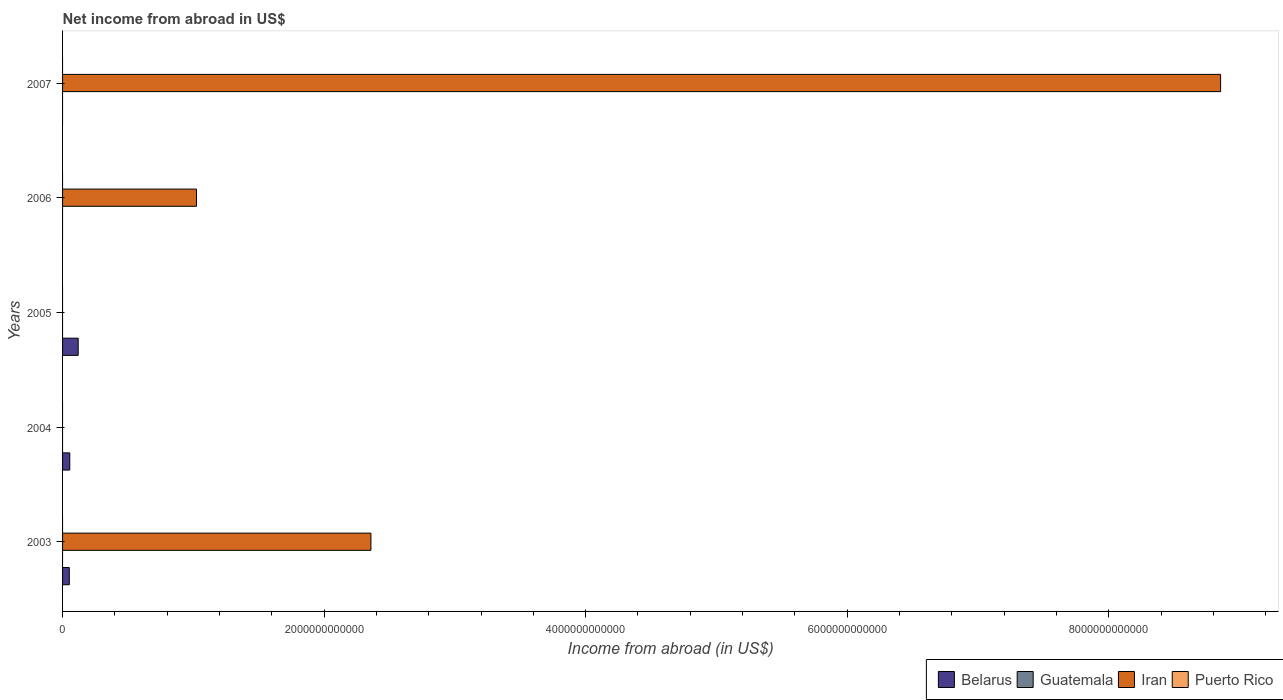Are the number of bars on each tick of the Y-axis equal?
Your answer should be very brief. No. What is the label of the 1st group of bars from the top?
Offer a very short reply. 2007. Across all years, what is the maximum net income from abroad in Iran?
Your answer should be very brief. 8.86e+12. Across all years, what is the minimum net income from abroad in Puerto Rico?
Offer a very short reply. 0. What is the difference between the net income from abroad in Iran in 2003 and that in 2006?
Your response must be concise. 1.33e+12. What is the difference between the net income from abroad in Belarus in 2007 and the net income from abroad in Iran in 2003?
Offer a very short reply. -2.36e+12. What is the average net income from abroad in Iran per year?
Offer a terse response. 2.45e+12. In the year 2003, what is the difference between the net income from abroad in Belarus and net income from abroad in Iran?
Your response must be concise. -2.31e+12. In how many years, is the net income from abroad in Belarus greater than 6000000000000 US$?
Your response must be concise. 0. What is the ratio of the net income from abroad in Belarus in 2004 to that in 2005?
Provide a short and direct response. 0.46. What is the difference between the highest and the lowest net income from abroad in Belarus?
Give a very brief answer. 1.20e+11. Is it the case that in every year, the sum of the net income from abroad in Belarus and net income from abroad in Iran is greater than the sum of net income from abroad in Puerto Rico and net income from abroad in Guatemala?
Your response must be concise. No. Is it the case that in every year, the sum of the net income from abroad in Guatemala and net income from abroad in Belarus is greater than the net income from abroad in Puerto Rico?
Your response must be concise. No. How many years are there in the graph?
Offer a very short reply. 5. What is the difference between two consecutive major ticks on the X-axis?
Ensure brevity in your answer.  2.00e+12. Are the values on the major ticks of X-axis written in scientific E-notation?
Keep it short and to the point. No. Does the graph contain grids?
Your answer should be compact. No. Where does the legend appear in the graph?
Provide a short and direct response. Bottom right. How many legend labels are there?
Give a very brief answer. 4. What is the title of the graph?
Your answer should be very brief. Net income from abroad in US$. Does "Middle East & North Africa (all income levels)" appear as one of the legend labels in the graph?
Provide a succinct answer. No. What is the label or title of the X-axis?
Provide a short and direct response. Income from abroad (in US$). What is the Income from abroad (in US$) in Belarus in 2003?
Your answer should be very brief. 5.15e+1. What is the Income from abroad (in US$) of Iran in 2003?
Keep it short and to the point. 2.36e+12. What is the Income from abroad (in US$) in Puerto Rico in 2003?
Make the answer very short. 0. What is the Income from abroad (in US$) in Belarus in 2004?
Your response must be concise. 5.51e+1. What is the Income from abroad (in US$) of Guatemala in 2004?
Ensure brevity in your answer.  0. What is the Income from abroad (in US$) of Iran in 2004?
Your answer should be compact. 0. What is the Income from abroad (in US$) in Puerto Rico in 2004?
Provide a succinct answer. 0. What is the Income from abroad (in US$) in Belarus in 2005?
Your answer should be very brief. 1.20e+11. What is the Income from abroad (in US$) in Guatemala in 2005?
Your answer should be very brief. 0. What is the Income from abroad (in US$) in Puerto Rico in 2005?
Provide a succinct answer. 0. What is the Income from abroad (in US$) of Iran in 2006?
Ensure brevity in your answer.  1.02e+12. What is the Income from abroad (in US$) in Puerto Rico in 2006?
Your answer should be very brief. 0. What is the Income from abroad (in US$) of Iran in 2007?
Keep it short and to the point. 8.86e+12. What is the Income from abroad (in US$) of Puerto Rico in 2007?
Make the answer very short. 0. Across all years, what is the maximum Income from abroad (in US$) in Belarus?
Keep it short and to the point. 1.20e+11. Across all years, what is the maximum Income from abroad (in US$) of Iran?
Give a very brief answer. 8.86e+12. Across all years, what is the minimum Income from abroad (in US$) of Iran?
Your response must be concise. 0. What is the total Income from abroad (in US$) of Belarus in the graph?
Your answer should be compact. 2.26e+11. What is the total Income from abroad (in US$) of Iran in the graph?
Keep it short and to the point. 1.22e+13. What is the difference between the Income from abroad (in US$) in Belarus in 2003 and that in 2004?
Keep it short and to the point. -3.60e+09. What is the difference between the Income from abroad (in US$) of Belarus in 2003 and that in 2005?
Make the answer very short. -6.80e+1. What is the difference between the Income from abroad (in US$) in Iran in 2003 and that in 2006?
Offer a very short reply. 1.33e+12. What is the difference between the Income from abroad (in US$) in Iran in 2003 and that in 2007?
Ensure brevity in your answer.  -6.50e+12. What is the difference between the Income from abroad (in US$) of Belarus in 2004 and that in 2005?
Ensure brevity in your answer.  -6.44e+1. What is the difference between the Income from abroad (in US$) of Iran in 2006 and that in 2007?
Offer a terse response. -7.83e+12. What is the difference between the Income from abroad (in US$) in Belarus in 2003 and the Income from abroad (in US$) in Iran in 2006?
Give a very brief answer. -9.73e+11. What is the difference between the Income from abroad (in US$) of Belarus in 2003 and the Income from abroad (in US$) of Iran in 2007?
Make the answer very short. -8.80e+12. What is the difference between the Income from abroad (in US$) in Belarus in 2004 and the Income from abroad (in US$) in Iran in 2006?
Ensure brevity in your answer.  -9.69e+11. What is the difference between the Income from abroad (in US$) in Belarus in 2004 and the Income from abroad (in US$) in Iran in 2007?
Give a very brief answer. -8.80e+12. What is the difference between the Income from abroad (in US$) of Belarus in 2005 and the Income from abroad (in US$) of Iran in 2006?
Give a very brief answer. -9.05e+11. What is the difference between the Income from abroad (in US$) in Belarus in 2005 and the Income from abroad (in US$) in Iran in 2007?
Keep it short and to the point. -8.74e+12. What is the average Income from abroad (in US$) of Belarus per year?
Provide a succinct answer. 4.52e+1. What is the average Income from abroad (in US$) of Guatemala per year?
Provide a succinct answer. 0. What is the average Income from abroad (in US$) in Iran per year?
Offer a terse response. 2.45e+12. What is the average Income from abroad (in US$) in Puerto Rico per year?
Provide a succinct answer. 0. In the year 2003, what is the difference between the Income from abroad (in US$) in Belarus and Income from abroad (in US$) in Iran?
Give a very brief answer. -2.31e+12. What is the ratio of the Income from abroad (in US$) in Belarus in 2003 to that in 2004?
Provide a succinct answer. 0.93. What is the ratio of the Income from abroad (in US$) of Belarus in 2003 to that in 2005?
Your answer should be compact. 0.43. What is the ratio of the Income from abroad (in US$) of Iran in 2003 to that in 2006?
Provide a short and direct response. 2.3. What is the ratio of the Income from abroad (in US$) in Iran in 2003 to that in 2007?
Offer a very short reply. 0.27. What is the ratio of the Income from abroad (in US$) of Belarus in 2004 to that in 2005?
Provide a succinct answer. 0.46. What is the ratio of the Income from abroad (in US$) of Iran in 2006 to that in 2007?
Make the answer very short. 0.12. What is the difference between the highest and the second highest Income from abroad (in US$) of Belarus?
Ensure brevity in your answer.  6.44e+1. What is the difference between the highest and the second highest Income from abroad (in US$) in Iran?
Provide a short and direct response. 6.50e+12. What is the difference between the highest and the lowest Income from abroad (in US$) of Belarus?
Your answer should be very brief. 1.20e+11. What is the difference between the highest and the lowest Income from abroad (in US$) of Iran?
Offer a terse response. 8.86e+12. 